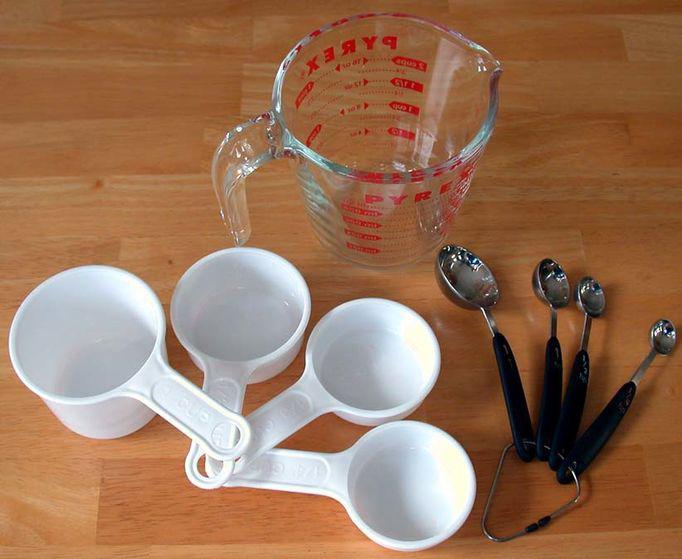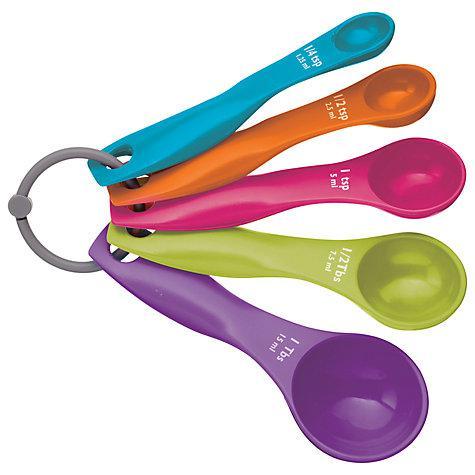The first image is the image on the left, the second image is the image on the right. For the images displayed, is the sentence "One image contains a multicolored measuring set" factually correct? Answer yes or no. Yes. 